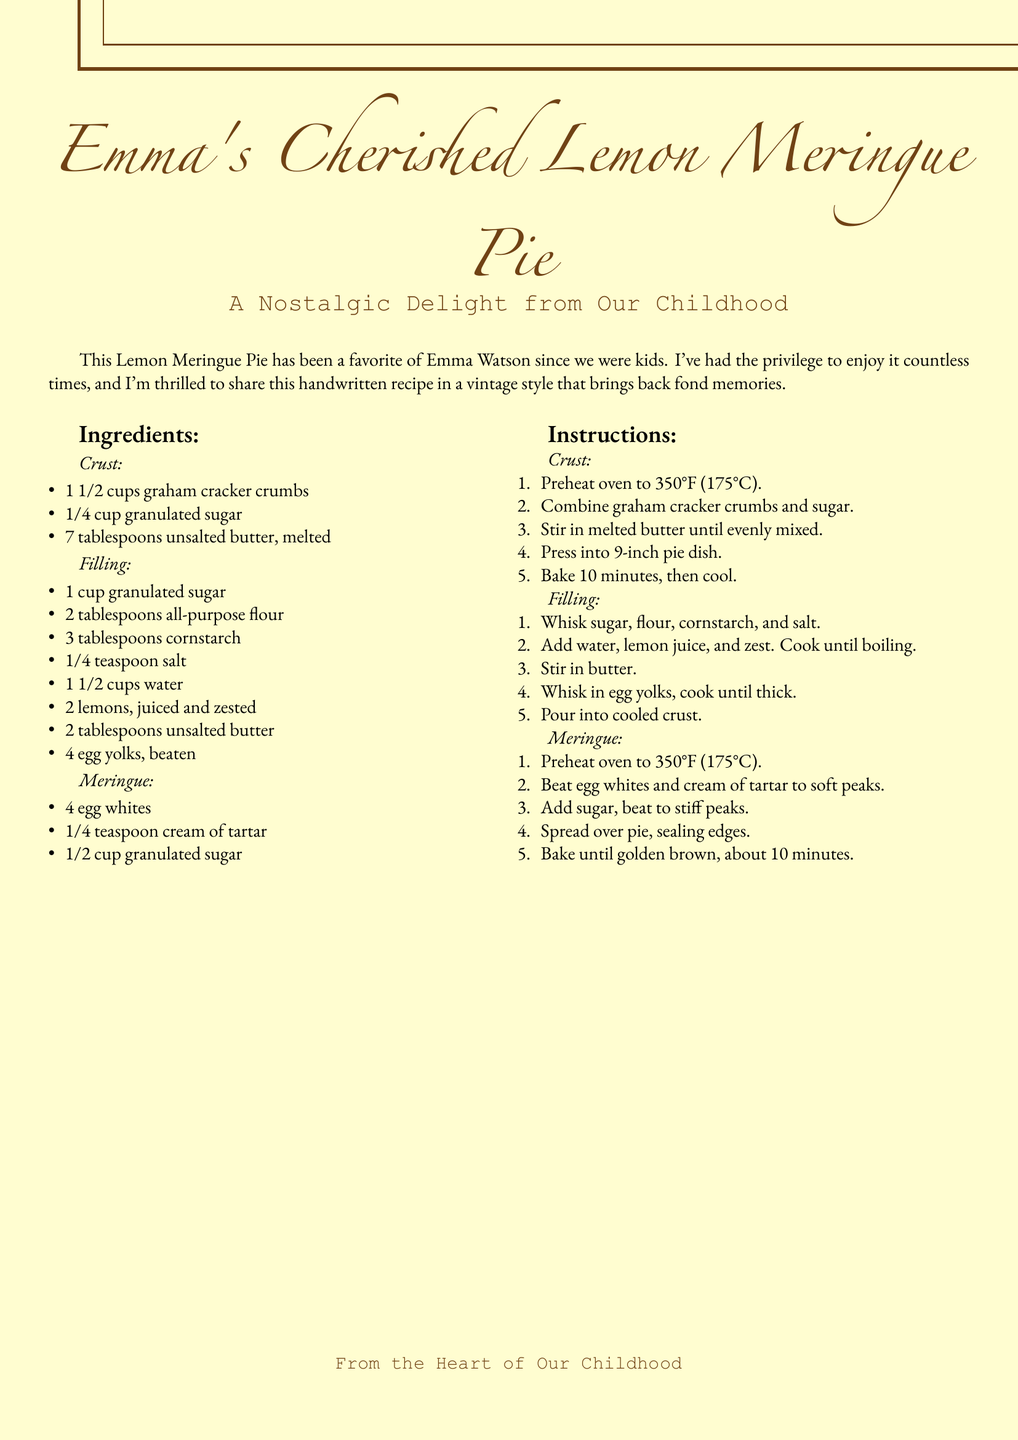What is the title of the recipe? The title is prominently displayed at the top of the document, identifying the recipe.
Answer: Emma's Cherished Lemon Meringue Pie Who is the recipe for? The recipe indicates a personal connection by naming the individual it is dedicated to.
Answer: Emma Watson How many tablespoons of butter are needed for the crust? The ingredient list specifies the amount of butter required for making the crust.
Answer: 7 tablespoons What is the main filling ingredient in this pie? The filling section of the recipe highlights the primary ingredient used for the filling.
Answer: Lemon juice What temperature should the oven be preheated to for baking? The instructions note the specific temperature needed to prepare the pie.
Answer: 350°F How long should the crust be baked? The instructions detail the duration for which the crust should be baked.
Answer: 10 minutes How many egg whites are used in the meringue? The meringue ingredient list clearly states the number of egg whites required.
Answer: 4 What type of sugar is used for the meringue? The ingredient list indicates the specific type of sugar called for in the meringue preparation.
Answer: Granulated sugar How many ingredients are listed for the filling? The filling section counts the total number of individual ingredients required.
Answer: 7 